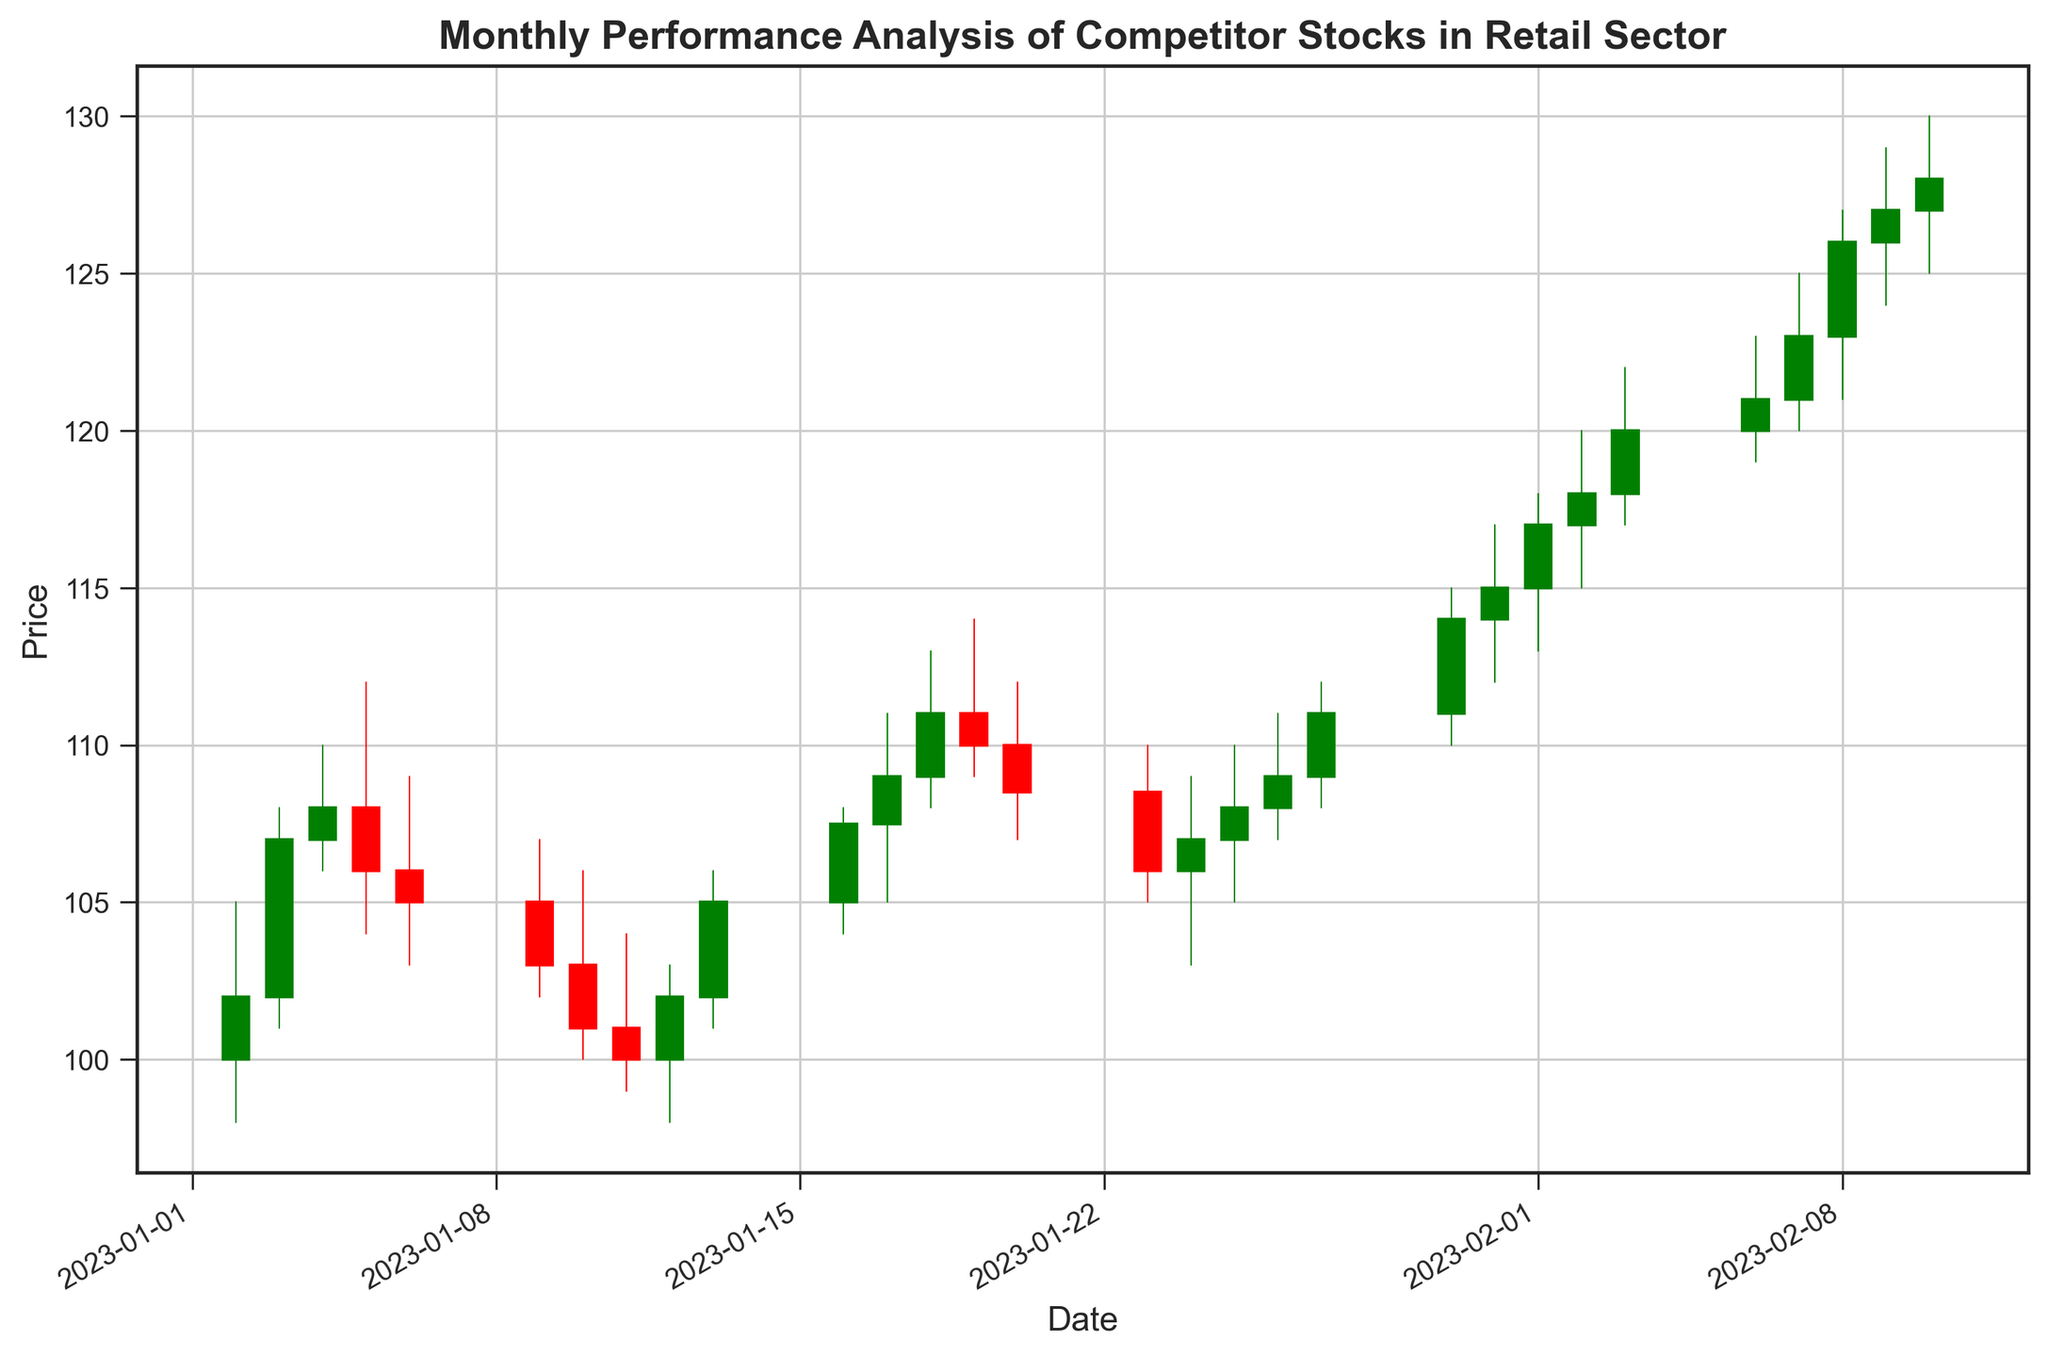What was the highest stock price in January? By looking at the highest points of the candlestick wicks in January, the highest price reached was on January 31st where the high was 117.00
Answer: 117.00 Which month showed a higher peak stock price, January or February? Compare the highest points of the candlestick wicks in January and February. January’s highest was 117.00 on January 31st, while February’s highest was 130.00 on February 10th
Answer: February On which date did the stock price close at its lowest in January? Observe the closing points of the candlestick bodies in January. The lowest closing price was on January 11th, at a price of 100.00
Answer: January 11 How did the closing price trend from the beginning to the end of January? Trace the closing points of the candlestick bodies from January 2nd (102.00) to January 31st (115.00). The trend shows an overall increase
Answer: Increase What is the average closing price for the month of February? Sum up all the closing prices for February (117.00 + 118.00 + 120.00 + 121.00 + 123.00 + 126.00 + 127.00 + 128.00) = 982.00 and divide by the number of days (8), so 982.00 / 8 = 122.75
Answer: 122.75 Did the volume of stock traded show any visible increasing trends in January? The volumes (represented as thin red-green vertical lines) generally start high at the beginning of January and fluctuate without a clear increasing trend. Volume peaked mid-January and then decreased
Answer: No Which day had the largest price range (difference between the high and the low price) in January? Calculate the high-low price differences for all January dates. On January 5th, the range is the largest (112.00 - 104.00 = 8.00)
Answer: January 5 What were the opening and closing prices on January 18th, and was it a bullish or bearish day? Look at the candlestick for January 18th, where the opening (bottom of the body) is 109.00 and the closing (top of the body) is 111.00. Since the closing price is higher, it was a bullish day
Answer: Open: 109.00, Close: 111.00, Bullish 